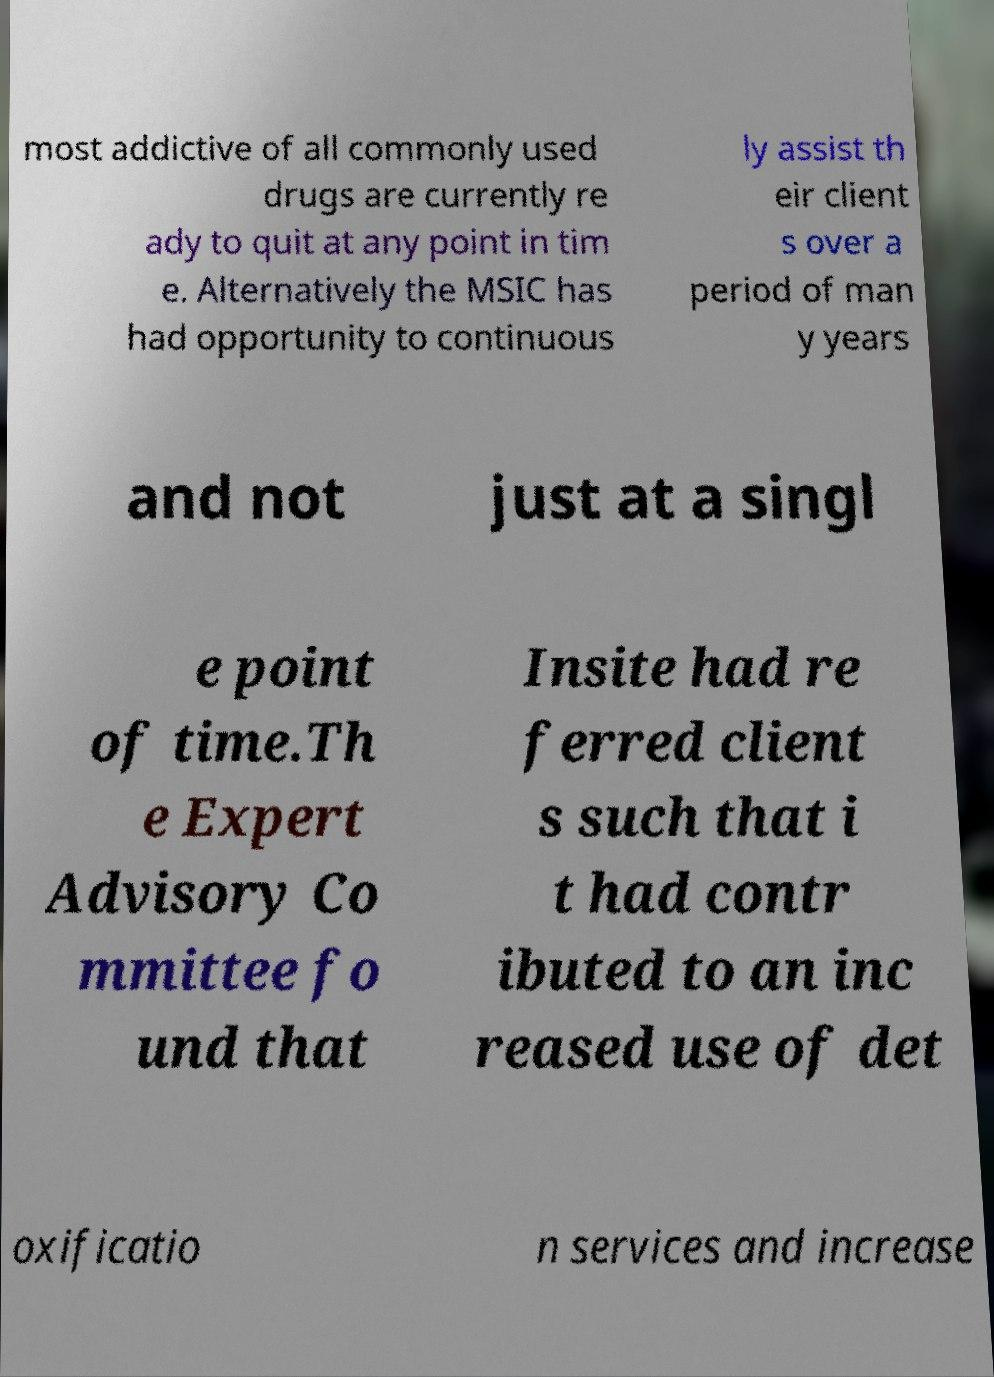Can you read and provide the text displayed in the image?This photo seems to have some interesting text. Can you extract and type it out for me? most addictive of all commonly used drugs are currently re ady to quit at any point in tim e. Alternatively the MSIC has had opportunity to continuous ly assist th eir client s over a period of man y years and not just at a singl e point of time.Th e Expert Advisory Co mmittee fo und that Insite had re ferred client s such that i t had contr ibuted to an inc reased use of det oxificatio n services and increase 